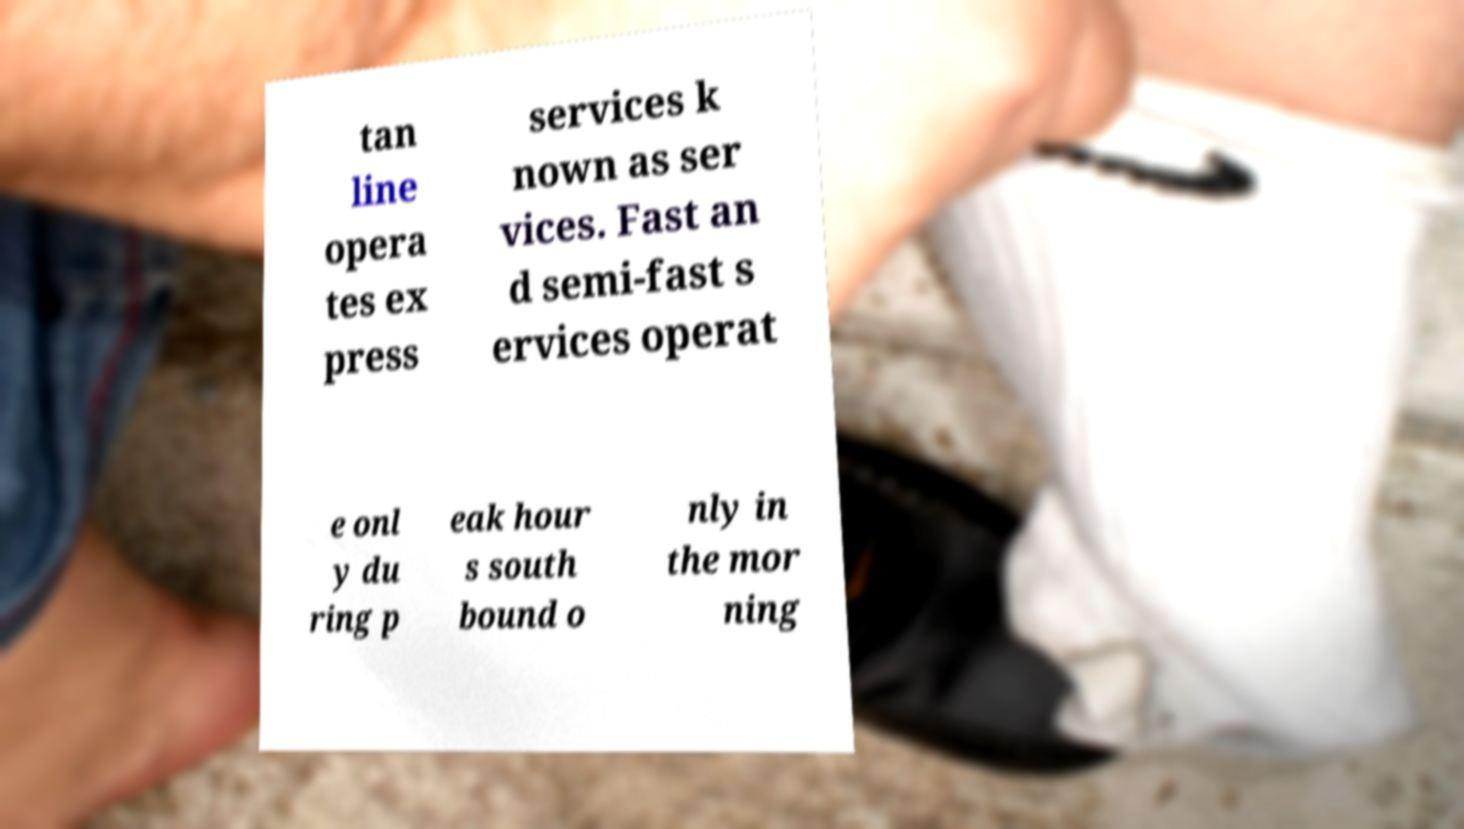Please read and relay the text visible in this image. What does it say? tan line opera tes ex press services k nown as ser vices. Fast an d semi-fast s ervices operat e onl y du ring p eak hour s south bound o nly in the mor ning 